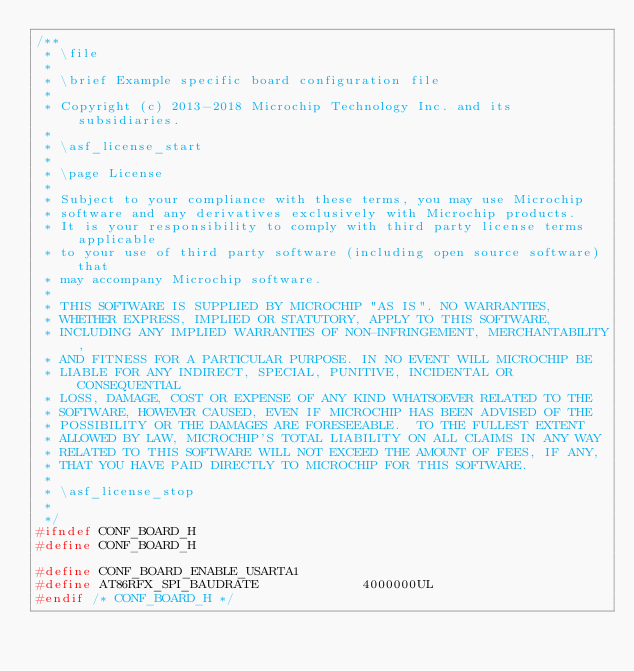<code> <loc_0><loc_0><loc_500><loc_500><_C_>/**
 * \file
 *
 * \brief Example specific board configuration file
 *
 * Copyright (c) 2013-2018 Microchip Technology Inc. and its subsidiaries.
 *
 * \asf_license_start
 *
 * \page License
 *
 * Subject to your compliance with these terms, you may use Microchip
 * software and any derivatives exclusively with Microchip products.
 * It is your responsibility to comply with third party license terms applicable
 * to your use of third party software (including open source software) that
 * may accompany Microchip software.
 *
 * THIS SOFTWARE IS SUPPLIED BY MICROCHIP "AS IS". NO WARRANTIES,
 * WHETHER EXPRESS, IMPLIED OR STATUTORY, APPLY TO THIS SOFTWARE,
 * INCLUDING ANY IMPLIED WARRANTIES OF NON-INFRINGEMENT, MERCHANTABILITY,
 * AND FITNESS FOR A PARTICULAR PURPOSE. IN NO EVENT WILL MICROCHIP BE
 * LIABLE FOR ANY INDIRECT, SPECIAL, PUNITIVE, INCIDENTAL OR CONSEQUENTIAL
 * LOSS, DAMAGE, COST OR EXPENSE OF ANY KIND WHATSOEVER RELATED TO THE
 * SOFTWARE, HOWEVER CAUSED, EVEN IF MICROCHIP HAS BEEN ADVISED OF THE
 * POSSIBILITY OR THE DAMAGES ARE FORESEEABLE.  TO THE FULLEST EXTENT
 * ALLOWED BY LAW, MICROCHIP'S TOTAL LIABILITY ON ALL CLAIMS IN ANY WAY
 * RELATED TO THIS SOFTWARE WILL NOT EXCEED THE AMOUNT OF FEES, IF ANY,
 * THAT YOU HAVE PAID DIRECTLY TO MICROCHIP FOR THIS SOFTWARE.
 *
 * \asf_license_stop
 *
 */
#ifndef CONF_BOARD_H
#define CONF_BOARD_H

#define CONF_BOARD_ENABLE_USARTA1
#define AT86RFX_SPI_BAUDRATE             4000000UL
#endif /* CONF_BOARD_H */
</code> 